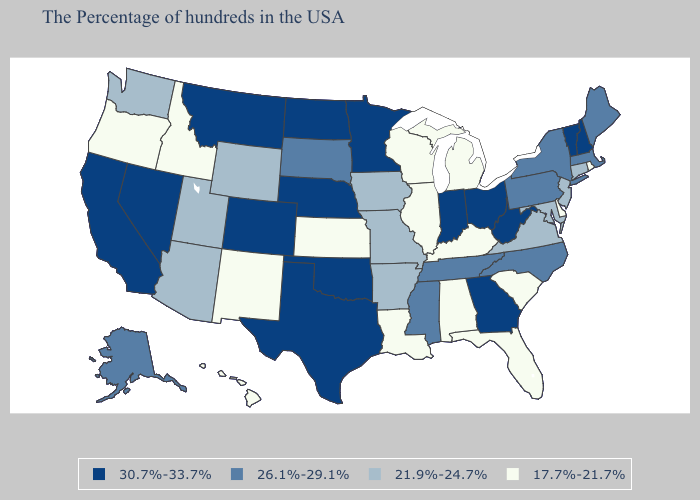Does Vermont have the lowest value in the Northeast?
Keep it brief. No. Name the states that have a value in the range 26.1%-29.1%?
Write a very short answer. Maine, Massachusetts, New York, Pennsylvania, North Carolina, Tennessee, Mississippi, South Dakota, Alaska. What is the lowest value in the USA?
Quick response, please. 17.7%-21.7%. Name the states that have a value in the range 17.7%-21.7%?
Quick response, please. Rhode Island, Delaware, South Carolina, Florida, Michigan, Kentucky, Alabama, Wisconsin, Illinois, Louisiana, Kansas, New Mexico, Idaho, Oregon, Hawaii. What is the value of Nevada?
Keep it brief. 30.7%-33.7%. What is the value of Nebraska?
Be succinct. 30.7%-33.7%. Which states hav the highest value in the West?
Answer briefly. Colorado, Montana, Nevada, California. How many symbols are there in the legend?
Give a very brief answer. 4. What is the lowest value in states that border Tennessee?
Be succinct. 17.7%-21.7%. Does the first symbol in the legend represent the smallest category?
Answer briefly. No. Name the states that have a value in the range 26.1%-29.1%?
Be succinct. Maine, Massachusetts, New York, Pennsylvania, North Carolina, Tennessee, Mississippi, South Dakota, Alaska. Does the map have missing data?
Give a very brief answer. No. 